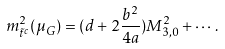Convert formula to latex. <formula><loc_0><loc_0><loc_500><loc_500>m _ { \tilde { t } ^ { c } } ^ { 2 } ( \mu _ { G } ) = ( d + 2 \frac { b ^ { 2 } } { 4 a } ) M _ { 3 , 0 } ^ { 2 } + \cdots .</formula> 